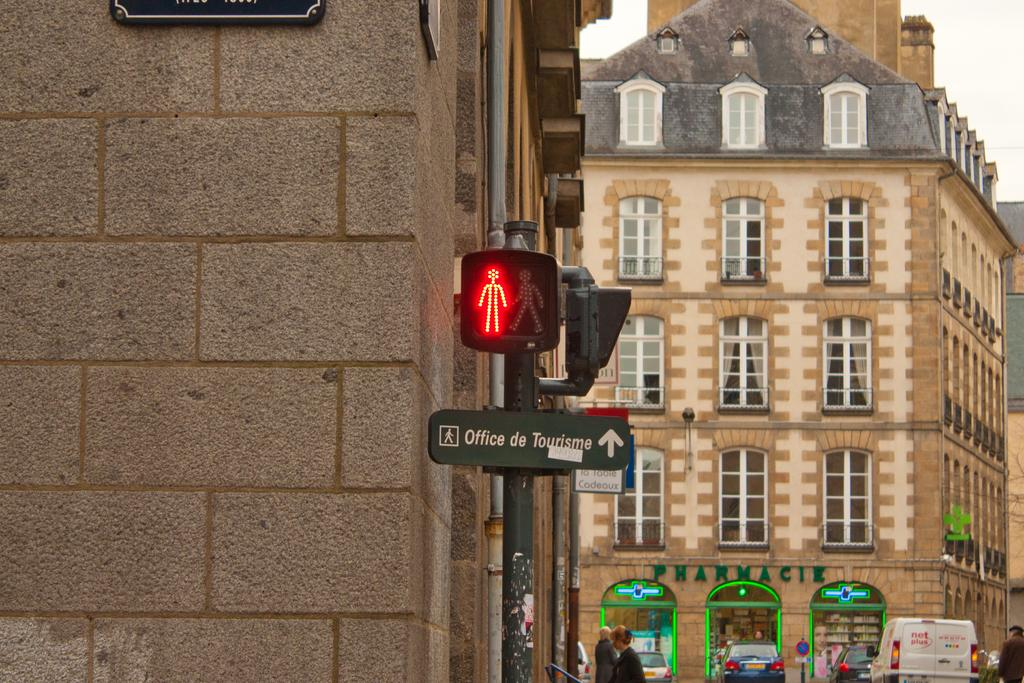<image>
Offer a succinct explanation of the picture presented. A street sign pointing toward the Office de Tourism straight ahead. 